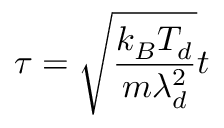Convert formula to latex. <formula><loc_0><loc_0><loc_500><loc_500>\tau = \sqrt { \frac { k _ { B } T _ { d } } { m \lambda _ { d } ^ { 2 } } } t</formula> 